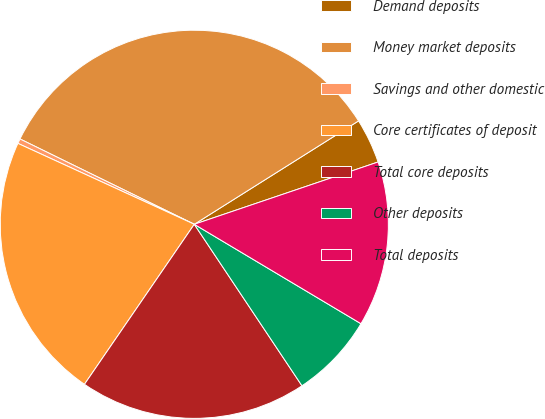Convert chart. <chart><loc_0><loc_0><loc_500><loc_500><pie_chart><fcel>Demand deposits<fcel>Money market deposits<fcel>Savings and other domestic<fcel>Core certificates of deposit<fcel>Total core deposits<fcel>Other deposits<fcel>Total deposits<nl><fcel>3.74%<fcel>33.81%<fcel>0.4%<fcel>22.27%<fcel>18.93%<fcel>7.08%<fcel>13.76%<nl></chart> 